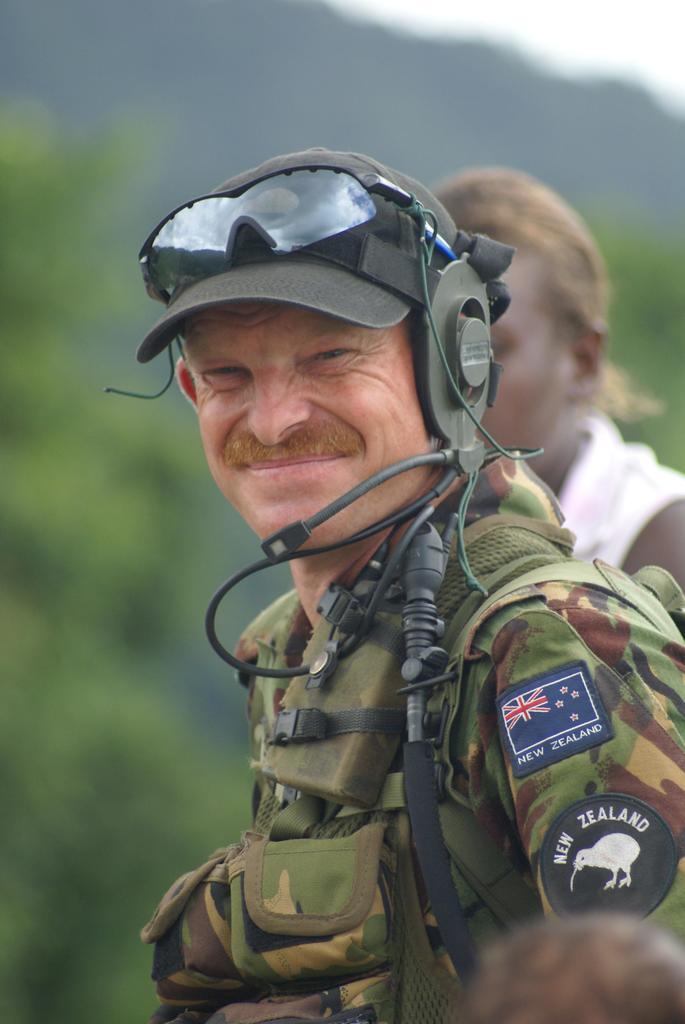Could you give a brief overview of what you see in this image? In the middle of the image a man is standing and smiling. Behind him a person is standing. Behind them there are some trees. Background of the image is blur. 